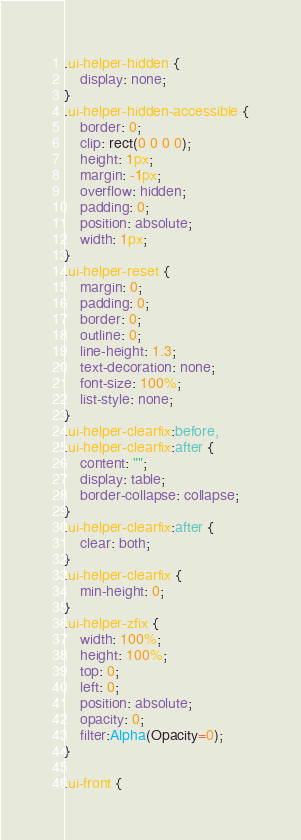Convert code to text. <code><loc_0><loc_0><loc_500><loc_500><_CSS_>
.ui-helper-hidden {
	display: none;
}
.ui-helper-hidden-accessible {
	border: 0;
	clip: rect(0 0 0 0);
	height: 1px;
	margin: -1px;
	overflow: hidden;
	padding: 0;
	position: absolute;
	width: 1px;
}
.ui-helper-reset {
	margin: 0;
	padding: 0;
	border: 0;
	outline: 0;
	line-height: 1.3;
	text-decoration: none;
	font-size: 100%;
	list-style: none;
}
.ui-helper-clearfix:before,
.ui-helper-clearfix:after {
	content: "";
	display: table;
	border-collapse: collapse;
}
.ui-helper-clearfix:after {
	clear: both;
}
.ui-helper-clearfix {
	min-height: 0;
}
.ui-helper-zfix {
	width: 100%;
	height: 100%;
	top: 0;
	left: 0;
	position: absolute;
	opacity: 0;
	filter:Alpha(Opacity=0);
}

.ui-front {</code> 